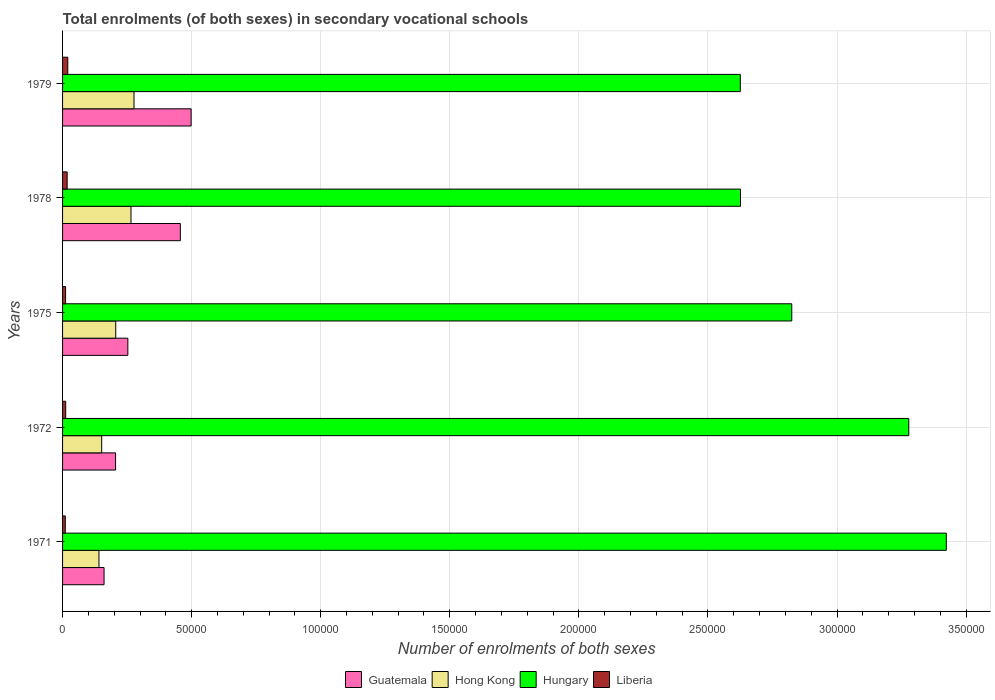How many bars are there on the 4th tick from the bottom?
Provide a short and direct response. 4. What is the number of enrolments in secondary schools in Hungary in 1979?
Your answer should be compact. 2.63e+05. Across all years, what is the maximum number of enrolments in secondary schools in Hong Kong?
Provide a short and direct response. 2.77e+04. Across all years, what is the minimum number of enrolments in secondary schools in Hong Kong?
Your answer should be compact. 1.41e+04. In which year was the number of enrolments in secondary schools in Hungary maximum?
Keep it short and to the point. 1971. In which year was the number of enrolments in secondary schools in Guatemala minimum?
Provide a short and direct response. 1971. What is the total number of enrolments in secondary schools in Guatemala in the graph?
Offer a terse response. 1.57e+05. What is the difference between the number of enrolments in secondary schools in Hong Kong in 1975 and that in 1978?
Give a very brief answer. -5904. What is the difference between the number of enrolments in secondary schools in Liberia in 1979 and the number of enrolments in secondary schools in Hungary in 1972?
Give a very brief answer. -3.26e+05. What is the average number of enrolments in secondary schools in Liberia per year?
Ensure brevity in your answer.  1448. In the year 1978, what is the difference between the number of enrolments in secondary schools in Liberia and number of enrolments in secondary schools in Hong Kong?
Your answer should be compact. -2.47e+04. In how many years, is the number of enrolments in secondary schools in Hong Kong greater than 20000 ?
Give a very brief answer. 3. What is the ratio of the number of enrolments in secondary schools in Liberia in 1972 to that in 1975?
Your response must be concise. 1.03. What is the difference between the highest and the second highest number of enrolments in secondary schools in Hungary?
Offer a very short reply. 1.45e+04. What is the difference between the highest and the lowest number of enrolments in secondary schools in Liberia?
Provide a short and direct response. 970. In how many years, is the number of enrolments in secondary schools in Guatemala greater than the average number of enrolments in secondary schools in Guatemala taken over all years?
Ensure brevity in your answer.  2. Is the sum of the number of enrolments in secondary schools in Hong Kong in 1972 and 1975 greater than the maximum number of enrolments in secondary schools in Hungary across all years?
Your response must be concise. No. Is it the case that in every year, the sum of the number of enrolments in secondary schools in Hungary and number of enrolments in secondary schools in Guatemala is greater than the sum of number of enrolments in secondary schools in Liberia and number of enrolments in secondary schools in Hong Kong?
Give a very brief answer. Yes. What does the 2nd bar from the top in 1979 represents?
Your answer should be very brief. Hungary. What does the 2nd bar from the bottom in 1975 represents?
Your response must be concise. Hong Kong. How many bars are there?
Ensure brevity in your answer.  20. Are all the bars in the graph horizontal?
Keep it short and to the point. Yes. Are the values on the major ticks of X-axis written in scientific E-notation?
Make the answer very short. No. Does the graph contain any zero values?
Provide a short and direct response. No. Does the graph contain grids?
Your answer should be very brief. Yes. How many legend labels are there?
Provide a short and direct response. 4. How are the legend labels stacked?
Keep it short and to the point. Horizontal. What is the title of the graph?
Make the answer very short. Total enrolments (of both sexes) in secondary vocational schools. What is the label or title of the X-axis?
Your answer should be very brief. Number of enrolments of both sexes. What is the label or title of the Y-axis?
Ensure brevity in your answer.  Years. What is the Number of enrolments of both sexes in Guatemala in 1971?
Make the answer very short. 1.61e+04. What is the Number of enrolments of both sexes in Hong Kong in 1971?
Offer a terse response. 1.41e+04. What is the Number of enrolments of both sexes in Hungary in 1971?
Ensure brevity in your answer.  3.42e+05. What is the Number of enrolments of both sexes of Liberia in 1971?
Provide a succinct answer. 1053. What is the Number of enrolments of both sexes of Guatemala in 1972?
Your answer should be very brief. 2.05e+04. What is the Number of enrolments of both sexes of Hong Kong in 1972?
Keep it short and to the point. 1.52e+04. What is the Number of enrolments of both sexes of Hungary in 1972?
Your answer should be compact. 3.28e+05. What is the Number of enrolments of both sexes in Liberia in 1972?
Your answer should be compact. 1213. What is the Number of enrolments of both sexes in Guatemala in 1975?
Keep it short and to the point. 2.53e+04. What is the Number of enrolments of both sexes of Hong Kong in 1975?
Ensure brevity in your answer.  2.06e+04. What is the Number of enrolments of both sexes in Hungary in 1975?
Provide a succinct answer. 2.82e+05. What is the Number of enrolments of both sexes in Liberia in 1975?
Provide a short and direct response. 1173. What is the Number of enrolments of both sexes of Guatemala in 1978?
Offer a terse response. 4.56e+04. What is the Number of enrolments of both sexes of Hong Kong in 1978?
Your answer should be compact. 2.65e+04. What is the Number of enrolments of both sexes in Hungary in 1978?
Offer a terse response. 2.63e+05. What is the Number of enrolments of both sexes in Liberia in 1978?
Ensure brevity in your answer.  1778. What is the Number of enrolments of both sexes of Guatemala in 1979?
Make the answer very short. 4.98e+04. What is the Number of enrolments of both sexes of Hong Kong in 1979?
Provide a short and direct response. 2.77e+04. What is the Number of enrolments of both sexes of Hungary in 1979?
Provide a succinct answer. 2.63e+05. What is the Number of enrolments of both sexes of Liberia in 1979?
Provide a short and direct response. 2023. Across all years, what is the maximum Number of enrolments of both sexes in Guatemala?
Keep it short and to the point. 4.98e+04. Across all years, what is the maximum Number of enrolments of both sexes of Hong Kong?
Offer a terse response. 2.77e+04. Across all years, what is the maximum Number of enrolments of both sexes in Hungary?
Offer a very short reply. 3.42e+05. Across all years, what is the maximum Number of enrolments of both sexes in Liberia?
Give a very brief answer. 2023. Across all years, what is the minimum Number of enrolments of both sexes in Guatemala?
Offer a terse response. 1.61e+04. Across all years, what is the minimum Number of enrolments of both sexes of Hong Kong?
Provide a succinct answer. 1.41e+04. Across all years, what is the minimum Number of enrolments of both sexes in Hungary?
Make the answer very short. 2.63e+05. Across all years, what is the minimum Number of enrolments of both sexes of Liberia?
Your response must be concise. 1053. What is the total Number of enrolments of both sexes in Guatemala in the graph?
Your response must be concise. 1.57e+05. What is the total Number of enrolments of both sexes in Hong Kong in the graph?
Your response must be concise. 1.04e+05. What is the total Number of enrolments of both sexes in Hungary in the graph?
Offer a very short reply. 1.48e+06. What is the total Number of enrolments of both sexes of Liberia in the graph?
Offer a very short reply. 7240. What is the difference between the Number of enrolments of both sexes in Guatemala in 1971 and that in 1972?
Your answer should be very brief. -4457. What is the difference between the Number of enrolments of both sexes in Hong Kong in 1971 and that in 1972?
Make the answer very short. -1052. What is the difference between the Number of enrolments of both sexes of Hungary in 1971 and that in 1972?
Provide a succinct answer. 1.45e+04. What is the difference between the Number of enrolments of both sexes in Liberia in 1971 and that in 1972?
Ensure brevity in your answer.  -160. What is the difference between the Number of enrolments of both sexes of Guatemala in 1971 and that in 1975?
Your answer should be very brief. -9210. What is the difference between the Number of enrolments of both sexes of Hong Kong in 1971 and that in 1975?
Provide a short and direct response. -6497. What is the difference between the Number of enrolments of both sexes in Hungary in 1971 and that in 1975?
Your response must be concise. 5.99e+04. What is the difference between the Number of enrolments of both sexes in Liberia in 1971 and that in 1975?
Provide a succinct answer. -120. What is the difference between the Number of enrolments of both sexes of Guatemala in 1971 and that in 1978?
Your response must be concise. -2.95e+04. What is the difference between the Number of enrolments of both sexes of Hong Kong in 1971 and that in 1978?
Offer a terse response. -1.24e+04. What is the difference between the Number of enrolments of both sexes of Hungary in 1971 and that in 1978?
Provide a short and direct response. 7.97e+04. What is the difference between the Number of enrolments of both sexes in Liberia in 1971 and that in 1978?
Ensure brevity in your answer.  -725. What is the difference between the Number of enrolments of both sexes of Guatemala in 1971 and that in 1979?
Provide a short and direct response. -3.37e+04. What is the difference between the Number of enrolments of both sexes of Hong Kong in 1971 and that in 1979?
Offer a terse response. -1.36e+04. What is the difference between the Number of enrolments of both sexes in Hungary in 1971 and that in 1979?
Your response must be concise. 7.98e+04. What is the difference between the Number of enrolments of both sexes in Liberia in 1971 and that in 1979?
Your response must be concise. -970. What is the difference between the Number of enrolments of both sexes of Guatemala in 1972 and that in 1975?
Your answer should be very brief. -4753. What is the difference between the Number of enrolments of both sexes of Hong Kong in 1972 and that in 1975?
Keep it short and to the point. -5445. What is the difference between the Number of enrolments of both sexes in Hungary in 1972 and that in 1975?
Offer a very short reply. 4.53e+04. What is the difference between the Number of enrolments of both sexes in Guatemala in 1972 and that in 1978?
Your answer should be very brief. -2.51e+04. What is the difference between the Number of enrolments of both sexes in Hong Kong in 1972 and that in 1978?
Your answer should be compact. -1.13e+04. What is the difference between the Number of enrolments of both sexes in Hungary in 1972 and that in 1978?
Offer a very short reply. 6.52e+04. What is the difference between the Number of enrolments of both sexes in Liberia in 1972 and that in 1978?
Your response must be concise. -565. What is the difference between the Number of enrolments of both sexes of Guatemala in 1972 and that in 1979?
Provide a succinct answer. -2.93e+04. What is the difference between the Number of enrolments of both sexes in Hong Kong in 1972 and that in 1979?
Ensure brevity in your answer.  -1.25e+04. What is the difference between the Number of enrolments of both sexes in Hungary in 1972 and that in 1979?
Provide a short and direct response. 6.53e+04. What is the difference between the Number of enrolments of both sexes in Liberia in 1972 and that in 1979?
Ensure brevity in your answer.  -810. What is the difference between the Number of enrolments of both sexes of Guatemala in 1975 and that in 1978?
Provide a succinct answer. -2.03e+04. What is the difference between the Number of enrolments of both sexes of Hong Kong in 1975 and that in 1978?
Offer a terse response. -5904. What is the difference between the Number of enrolments of both sexes of Hungary in 1975 and that in 1978?
Offer a very short reply. 1.99e+04. What is the difference between the Number of enrolments of both sexes of Liberia in 1975 and that in 1978?
Give a very brief answer. -605. What is the difference between the Number of enrolments of both sexes in Guatemala in 1975 and that in 1979?
Provide a short and direct response. -2.45e+04. What is the difference between the Number of enrolments of both sexes of Hong Kong in 1975 and that in 1979?
Keep it short and to the point. -7075. What is the difference between the Number of enrolments of both sexes in Hungary in 1975 and that in 1979?
Your answer should be compact. 1.99e+04. What is the difference between the Number of enrolments of both sexes of Liberia in 1975 and that in 1979?
Keep it short and to the point. -850. What is the difference between the Number of enrolments of both sexes in Guatemala in 1978 and that in 1979?
Provide a succinct answer. -4187. What is the difference between the Number of enrolments of both sexes of Hong Kong in 1978 and that in 1979?
Ensure brevity in your answer.  -1171. What is the difference between the Number of enrolments of both sexes in Liberia in 1978 and that in 1979?
Your answer should be very brief. -245. What is the difference between the Number of enrolments of both sexes in Guatemala in 1971 and the Number of enrolments of both sexes in Hong Kong in 1972?
Keep it short and to the point. 920. What is the difference between the Number of enrolments of both sexes in Guatemala in 1971 and the Number of enrolments of both sexes in Hungary in 1972?
Give a very brief answer. -3.12e+05. What is the difference between the Number of enrolments of both sexes of Guatemala in 1971 and the Number of enrolments of both sexes of Liberia in 1972?
Keep it short and to the point. 1.49e+04. What is the difference between the Number of enrolments of both sexes of Hong Kong in 1971 and the Number of enrolments of both sexes of Hungary in 1972?
Offer a terse response. -3.14e+05. What is the difference between the Number of enrolments of both sexes in Hong Kong in 1971 and the Number of enrolments of both sexes in Liberia in 1972?
Provide a short and direct response. 1.29e+04. What is the difference between the Number of enrolments of both sexes in Hungary in 1971 and the Number of enrolments of both sexes in Liberia in 1972?
Make the answer very short. 3.41e+05. What is the difference between the Number of enrolments of both sexes of Guatemala in 1971 and the Number of enrolments of both sexes of Hong Kong in 1975?
Ensure brevity in your answer.  -4525. What is the difference between the Number of enrolments of both sexes of Guatemala in 1971 and the Number of enrolments of both sexes of Hungary in 1975?
Your answer should be very brief. -2.66e+05. What is the difference between the Number of enrolments of both sexes in Guatemala in 1971 and the Number of enrolments of both sexes in Liberia in 1975?
Ensure brevity in your answer.  1.49e+04. What is the difference between the Number of enrolments of both sexes in Hong Kong in 1971 and the Number of enrolments of both sexes in Hungary in 1975?
Offer a very short reply. -2.68e+05. What is the difference between the Number of enrolments of both sexes of Hong Kong in 1971 and the Number of enrolments of both sexes of Liberia in 1975?
Provide a succinct answer. 1.29e+04. What is the difference between the Number of enrolments of both sexes of Hungary in 1971 and the Number of enrolments of both sexes of Liberia in 1975?
Offer a terse response. 3.41e+05. What is the difference between the Number of enrolments of both sexes of Guatemala in 1971 and the Number of enrolments of both sexes of Hong Kong in 1978?
Provide a short and direct response. -1.04e+04. What is the difference between the Number of enrolments of both sexes in Guatemala in 1971 and the Number of enrolments of both sexes in Hungary in 1978?
Offer a terse response. -2.47e+05. What is the difference between the Number of enrolments of both sexes of Guatemala in 1971 and the Number of enrolments of both sexes of Liberia in 1978?
Offer a terse response. 1.43e+04. What is the difference between the Number of enrolments of both sexes of Hong Kong in 1971 and the Number of enrolments of both sexes of Hungary in 1978?
Keep it short and to the point. -2.49e+05. What is the difference between the Number of enrolments of both sexes of Hong Kong in 1971 and the Number of enrolments of both sexes of Liberia in 1978?
Ensure brevity in your answer.  1.23e+04. What is the difference between the Number of enrolments of both sexes in Hungary in 1971 and the Number of enrolments of both sexes in Liberia in 1978?
Give a very brief answer. 3.41e+05. What is the difference between the Number of enrolments of both sexes of Guatemala in 1971 and the Number of enrolments of both sexes of Hong Kong in 1979?
Your response must be concise. -1.16e+04. What is the difference between the Number of enrolments of both sexes of Guatemala in 1971 and the Number of enrolments of both sexes of Hungary in 1979?
Provide a short and direct response. -2.46e+05. What is the difference between the Number of enrolments of both sexes in Guatemala in 1971 and the Number of enrolments of both sexes in Liberia in 1979?
Your response must be concise. 1.41e+04. What is the difference between the Number of enrolments of both sexes in Hong Kong in 1971 and the Number of enrolments of both sexes in Hungary in 1979?
Give a very brief answer. -2.48e+05. What is the difference between the Number of enrolments of both sexes of Hong Kong in 1971 and the Number of enrolments of both sexes of Liberia in 1979?
Offer a terse response. 1.21e+04. What is the difference between the Number of enrolments of both sexes in Hungary in 1971 and the Number of enrolments of both sexes in Liberia in 1979?
Your response must be concise. 3.40e+05. What is the difference between the Number of enrolments of both sexes in Guatemala in 1972 and the Number of enrolments of both sexes in Hong Kong in 1975?
Provide a short and direct response. -68. What is the difference between the Number of enrolments of both sexes in Guatemala in 1972 and the Number of enrolments of both sexes in Hungary in 1975?
Your answer should be compact. -2.62e+05. What is the difference between the Number of enrolments of both sexes of Guatemala in 1972 and the Number of enrolments of both sexes of Liberia in 1975?
Give a very brief answer. 1.94e+04. What is the difference between the Number of enrolments of both sexes of Hong Kong in 1972 and the Number of enrolments of both sexes of Hungary in 1975?
Your response must be concise. -2.67e+05. What is the difference between the Number of enrolments of both sexes in Hong Kong in 1972 and the Number of enrolments of both sexes in Liberia in 1975?
Provide a short and direct response. 1.40e+04. What is the difference between the Number of enrolments of both sexes of Hungary in 1972 and the Number of enrolments of both sexes of Liberia in 1975?
Your answer should be compact. 3.27e+05. What is the difference between the Number of enrolments of both sexes of Guatemala in 1972 and the Number of enrolments of both sexes of Hong Kong in 1978?
Your answer should be compact. -5972. What is the difference between the Number of enrolments of both sexes of Guatemala in 1972 and the Number of enrolments of both sexes of Hungary in 1978?
Your response must be concise. -2.42e+05. What is the difference between the Number of enrolments of both sexes of Guatemala in 1972 and the Number of enrolments of both sexes of Liberia in 1978?
Give a very brief answer. 1.88e+04. What is the difference between the Number of enrolments of both sexes of Hong Kong in 1972 and the Number of enrolments of both sexes of Hungary in 1978?
Provide a succinct answer. -2.47e+05. What is the difference between the Number of enrolments of both sexes in Hong Kong in 1972 and the Number of enrolments of both sexes in Liberia in 1978?
Keep it short and to the point. 1.34e+04. What is the difference between the Number of enrolments of both sexes of Hungary in 1972 and the Number of enrolments of both sexes of Liberia in 1978?
Offer a terse response. 3.26e+05. What is the difference between the Number of enrolments of both sexes in Guatemala in 1972 and the Number of enrolments of both sexes in Hong Kong in 1979?
Offer a terse response. -7143. What is the difference between the Number of enrolments of both sexes in Guatemala in 1972 and the Number of enrolments of both sexes in Hungary in 1979?
Ensure brevity in your answer.  -2.42e+05. What is the difference between the Number of enrolments of both sexes in Guatemala in 1972 and the Number of enrolments of both sexes in Liberia in 1979?
Offer a terse response. 1.85e+04. What is the difference between the Number of enrolments of both sexes in Hong Kong in 1972 and the Number of enrolments of both sexes in Hungary in 1979?
Provide a succinct answer. -2.47e+05. What is the difference between the Number of enrolments of both sexes in Hong Kong in 1972 and the Number of enrolments of both sexes in Liberia in 1979?
Offer a very short reply. 1.31e+04. What is the difference between the Number of enrolments of both sexes of Hungary in 1972 and the Number of enrolments of both sexes of Liberia in 1979?
Provide a short and direct response. 3.26e+05. What is the difference between the Number of enrolments of both sexes of Guatemala in 1975 and the Number of enrolments of both sexes of Hong Kong in 1978?
Provide a succinct answer. -1219. What is the difference between the Number of enrolments of both sexes of Guatemala in 1975 and the Number of enrolments of both sexes of Hungary in 1978?
Make the answer very short. -2.37e+05. What is the difference between the Number of enrolments of both sexes in Guatemala in 1975 and the Number of enrolments of both sexes in Liberia in 1978?
Provide a succinct answer. 2.35e+04. What is the difference between the Number of enrolments of both sexes in Hong Kong in 1975 and the Number of enrolments of both sexes in Hungary in 1978?
Offer a very short reply. -2.42e+05. What is the difference between the Number of enrolments of both sexes of Hong Kong in 1975 and the Number of enrolments of both sexes of Liberia in 1978?
Your answer should be compact. 1.88e+04. What is the difference between the Number of enrolments of both sexes of Hungary in 1975 and the Number of enrolments of both sexes of Liberia in 1978?
Provide a short and direct response. 2.81e+05. What is the difference between the Number of enrolments of both sexes in Guatemala in 1975 and the Number of enrolments of both sexes in Hong Kong in 1979?
Offer a very short reply. -2390. What is the difference between the Number of enrolments of both sexes in Guatemala in 1975 and the Number of enrolments of both sexes in Hungary in 1979?
Give a very brief answer. -2.37e+05. What is the difference between the Number of enrolments of both sexes in Guatemala in 1975 and the Number of enrolments of both sexes in Liberia in 1979?
Offer a very short reply. 2.33e+04. What is the difference between the Number of enrolments of both sexes of Hong Kong in 1975 and the Number of enrolments of both sexes of Hungary in 1979?
Your response must be concise. -2.42e+05. What is the difference between the Number of enrolments of both sexes of Hong Kong in 1975 and the Number of enrolments of both sexes of Liberia in 1979?
Offer a very short reply. 1.86e+04. What is the difference between the Number of enrolments of both sexes of Hungary in 1975 and the Number of enrolments of both sexes of Liberia in 1979?
Offer a terse response. 2.80e+05. What is the difference between the Number of enrolments of both sexes in Guatemala in 1978 and the Number of enrolments of both sexes in Hong Kong in 1979?
Provide a succinct answer. 1.79e+04. What is the difference between the Number of enrolments of both sexes in Guatemala in 1978 and the Number of enrolments of both sexes in Hungary in 1979?
Ensure brevity in your answer.  -2.17e+05. What is the difference between the Number of enrolments of both sexes of Guatemala in 1978 and the Number of enrolments of both sexes of Liberia in 1979?
Give a very brief answer. 4.36e+04. What is the difference between the Number of enrolments of both sexes of Hong Kong in 1978 and the Number of enrolments of both sexes of Hungary in 1979?
Your answer should be compact. -2.36e+05. What is the difference between the Number of enrolments of both sexes in Hong Kong in 1978 and the Number of enrolments of both sexes in Liberia in 1979?
Offer a terse response. 2.45e+04. What is the difference between the Number of enrolments of both sexes in Hungary in 1978 and the Number of enrolments of both sexes in Liberia in 1979?
Make the answer very short. 2.61e+05. What is the average Number of enrolments of both sexes in Guatemala per year?
Make the answer very short. 3.15e+04. What is the average Number of enrolments of both sexes of Hong Kong per year?
Your response must be concise. 2.08e+04. What is the average Number of enrolments of both sexes in Hungary per year?
Provide a short and direct response. 2.96e+05. What is the average Number of enrolments of both sexes of Liberia per year?
Give a very brief answer. 1448. In the year 1971, what is the difference between the Number of enrolments of both sexes in Guatemala and Number of enrolments of both sexes in Hong Kong?
Keep it short and to the point. 1972. In the year 1971, what is the difference between the Number of enrolments of both sexes of Guatemala and Number of enrolments of both sexes of Hungary?
Make the answer very short. -3.26e+05. In the year 1971, what is the difference between the Number of enrolments of both sexes of Guatemala and Number of enrolments of both sexes of Liberia?
Offer a terse response. 1.50e+04. In the year 1971, what is the difference between the Number of enrolments of both sexes of Hong Kong and Number of enrolments of both sexes of Hungary?
Provide a succinct answer. -3.28e+05. In the year 1971, what is the difference between the Number of enrolments of both sexes of Hong Kong and Number of enrolments of both sexes of Liberia?
Keep it short and to the point. 1.31e+04. In the year 1971, what is the difference between the Number of enrolments of both sexes of Hungary and Number of enrolments of both sexes of Liberia?
Provide a succinct answer. 3.41e+05. In the year 1972, what is the difference between the Number of enrolments of both sexes in Guatemala and Number of enrolments of both sexes in Hong Kong?
Ensure brevity in your answer.  5377. In the year 1972, what is the difference between the Number of enrolments of both sexes in Guatemala and Number of enrolments of both sexes in Hungary?
Your answer should be compact. -3.07e+05. In the year 1972, what is the difference between the Number of enrolments of both sexes in Guatemala and Number of enrolments of both sexes in Liberia?
Offer a terse response. 1.93e+04. In the year 1972, what is the difference between the Number of enrolments of both sexes in Hong Kong and Number of enrolments of both sexes in Hungary?
Your answer should be very brief. -3.13e+05. In the year 1972, what is the difference between the Number of enrolments of both sexes in Hong Kong and Number of enrolments of both sexes in Liberia?
Give a very brief answer. 1.39e+04. In the year 1972, what is the difference between the Number of enrolments of both sexes in Hungary and Number of enrolments of both sexes in Liberia?
Your response must be concise. 3.27e+05. In the year 1975, what is the difference between the Number of enrolments of both sexes of Guatemala and Number of enrolments of both sexes of Hong Kong?
Offer a terse response. 4685. In the year 1975, what is the difference between the Number of enrolments of both sexes of Guatemala and Number of enrolments of both sexes of Hungary?
Provide a succinct answer. -2.57e+05. In the year 1975, what is the difference between the Number of enrolments of both sexes in Guatemala and Number of enrolments of both sexes in Liberia?
Provide a succinct answer. 2.41e+04. In the year 1975, what is the difference between the Number of enrolments of both sexes of Hong Kong and Number of enrolments of both sexes of Hungary?
Ensure brevity in your answer.  -2.62e+05. In the year 1975, what is the difference between the Number of enrolments of both sexes of Hong Kong and Number of enrolments of both sexes of Liberia?
Give a very brief answer. 1.94e+04. In the year 1975, what is the difference between the Number of enrolments of both sexes in Hungary and Number of enrolments of both sexes in Liberia?
Keep it short and to the point. 2.81e+05. In the year 1978, what is the difference between the Number of enrolments of both sexes in Guatemala and Number of enrolments of both sexes in Hong Kong?
Your answer should be very brief. 1.91e+04. In the year 1978, what is the difference between the Number of enrolments of both sexes in Guatemala and Number of enrolments of both sexes in Hungary?
Give a very brief answer. -2.17e+05. In the year 1978, what is the difference between the Number of enrolments of both sexes of Guatemala and Number of enrolments of both sexes of Liberia?
Offer a terse response. 4.38e+04. In the year 1978, what is the difference between the Number of enrolments of both sexes of Hong Kong and Number of enrolments of both sexes of Hungary?
Keep it short and to the point. -2.36e+05. In the year 1978, what is the difference between the Number of enrolments of both sexes in Hong Kong and Number of enrolments of both sexes in Liberia?
Your response must be concise. 2.47e+04. In the year 1978, what is the difference between the Number of enrolments of both sexes of Hungary and Number of enrolments of both sexes of Liberia?
Ensure brevity in your answer.  2.61e+05. In the year 1979, what is the difference between the Number of enrolments of both sexes in Guatemala and Number of enrolments of both sexes in Hong Kong?
Your answer should be compact. 2.21e+04. In the year 1979, what is the difference between the Number of enrolments of both sexes in Guatemala and Number of enrolments of both sexes in Hungary?
Provide a succinct answer. -2.13e+05. In the year 1979, what is the difference between the Number of enrolments of both sexes in Guatemala and Number of enrolments of both sexes in Liberia?
Keep it short and to the point. 4.78e+04. In the year 1979, what is the difference between the Number of enrolments of both sexes in Hong Kong and Number of enrolments of both sexes in Hungary?
Ensure brevity in your answer.  -2.35e+05. In the year 1979, what is the difference between the Number of enrolments of both sexes of Hong Kong and Number of enrolments of both sexes of Liberia?
Provide a short and direct response. 2.57e+04. In the year 1979, what is the difference between the Number of enrolments of both sexes of Hungary and Number of enrolments of both sexes of Liberia?
Provide a short and direct response. 2.61e+05. What is the ratio of the Number of enrolments of both sexes in Guatemala in 1971 to that in 1972?
Your answer should be very brief. 0.78. What is the ratio of the Number of enrolments of both sexes of Hong Kong in 1971 to that in 1972?
Your answer should be compact. 0.93. What is the ratio of the Number of enrolments of both sexes of Hungary in 1971 to that in 1972?
Provide a short and direct response. 1.04. What is the ratio of the Number of enrolments of both sexes in Liberia in 1971 to that in 1972?
Your answer should be very brief. 0.87. What is the ratio of the Number of enrolments of both sexes in Guatemala in 1971 to that in 1975?
Your answer should be very brief. 0.64. What is the ratio of the Number of enrolments of both sexes in Hong Kong in 1971 to that in 1975?
Offer a very short reply. 0.68. What is the ratio of the Number of enrolments of both sexes in Hungary in 1971 to that in 1975?
Offer a terse response. 1.21. What is the ratio of the Number of enrolments of both sexes of Liberia in 1971 to that in 1975?
Give a very brief answer. 0.9. What is the ratio of the Number of enrolments of both sexes in Guatemala in 1971 to that in 1978?
Provide a succinct answer. 0.35. What is the ratio of the Number of enrolments of both sexes in Hong Kong in 1971 to that in 1978?
Your answer should be very brief. 0.53. What is the ratio of the Number of enrolments of both sexes in Hungary in 1971 to that in 1978?
Give a very brief answer. 1.3. What is the ratio of the Number of enrolments of both sexes of Liberia in 1971 to that in 1978?
Offer a terse response. 0.59. What is the ratio of the Number of enrolments of both sexes in Guatemala in 1971 to that in 1979?
Provide a short and direct response. 0.32. What is the ratio of the Number of enrolments of both sexes of Hong Kong in 1971 to that in 1979?
Offer a very short reply. 0.51. What is the ratio of the Number of enrolments of both sexes in Hungary in 1971 to that in 1979?
Your answer should be compact. 1.3. What is the ratio of the Number of enrolments of both sexes in Liberia in 1971 to that in 1979?
Your answer should be very brief. 0.52. What is the ratio of the Number of enrolments of both sexes in Guatemala in 1972 to that in 1975?
Give a very brief answer. 0.81. What is the ratio of the Number of enrolments of both sexes in Hong Kong in 1972 to that in 1975?
Ensure brevity in your answer.  0.74. What is the ratio of the Number of enrolments of both sexes of Hungary in 1972 to that in 1975?
Ensure brevity in your answer.  1.16. What is the ratio of the Number of enrolments of both sexes of Liberia in 1972 to that in 1975?
Offer a very short reply. 1.03. What is the ratio of the Number of enrolments of both sexes in Guatemala in 1972 to that in 1978?
Your response must be concise. 0.45. What is the ratio of the Number of enrolments of both sexes in Hong Kong in 1972 to that in 1978?
Provide a succinct answer. 0.57. What is the ratio of the Number of enrolments of both sexes of Hungary in 1972 to that in 1978?
Offer a very short reply. 1.25. What is the ratio of the Number of enrolments of both sexes of Liberia in 1972 to that in 1978?
Provide a short and direct response. 0.68. What is the ratio of the Number of enrolments of both sexes of Guatemala in 1972 to that in 1979?
Keep it short and to the point. 0.41. What is the ratio of the Number of enrolments of both sexes in Hong Kong in 1972 to that in 1979?
Give a very brief answer. 0.55. What is the ratio of the Number of enrolments of both sexes of Hungary in 1972 to that in 1979?
Provide a succinct answer. 1.25. What is the ratio of the Number of enrolments of both sexes of Liberia in 1972 to that in 1979?
Offer a very short reply. 0.6. What is the ratio of the Number of enrolments of both sexes in Guatemala in 1975 to that in 1978?
Your answer should be compact. 0.55. What is the ratio of the Number of enrolments of both sexes in Hong Kong in 1975 to that in 1978?
Your answer should be very brief. 0.78. What is the ratio of the Number of enrolments of both sexes in Hungary in 1975 to that in 1978?
Your answer should be very brief. 1.08. What is the ratio of the Number of enrolments of both sexes of Liberia in 1975 to that in 1978?
Offer a terse response. 0.66. What is the ratio of the Number of enrolments of both sexes in Guatemala in 1975 to that in 1979?
Make the answer very short. 0.51. What is the ratio of the Number of enrolments of both sexes of Hong Kong in 1975 to that in 1979?
Offer a very short reply. 0.74. What is the ratio of the Number of enrolments of both sexes in Hungary in 1975 to that in 1979?
Offer a very short reply. 1.08. What is the ratio of the Number of enrolments of both sexes of Liberia in 1975 to that in 1979?
Make the answer very short. 0.58. What is the ratio of the Number of enrolments of both sexes in Guatemala in 1978 to that in 1979?
Provide a short and direct response. 0.92. What is the ratio of the Number of enrolments of both sexes in Hong Kong in 1978 to that in 1979?
Make the answer very short. 0.96. What is the ratio of the Number of enrolments of both sexes of Liberia in 1978 to that in 1979?
Your answer should be compact. 0.88. What is the difference between the highest and the second highest Number of enrolments of both sexes of Guatemala?
Offer a very short reply. 4187. What is the difference between the highest and the second highest Number of enrolments of both sexes of Hong Kong?
Your answer should be compact. 1171. What is the difference between the highest and the second highest Number of enrolments of both sexes of Hungary?
Your answer should be very brief. 1.45e+04. What is the difference between the highest and the second highest Number of enrolments of both sexes in Liberia?
Your response must be concise. 245. What is the difference between the highest and the lowest Number of enrolments of both sexes in Guatemala?
Give a very brief answer. 3.37e+04. What is the difference between the highest and the lowest Number of enrolments of both sexes in Hong Kong?
Your answer should be compact. 1.36e+04. What is the difference between the highest and the lowest Number of enrolments of both sexes of Hungary?
Your response must be concise. 7.98e+04. What is the difference between the highest and the lowest Number of enrolments of both sexes in Liberia?
Your response must be concise. 970. 